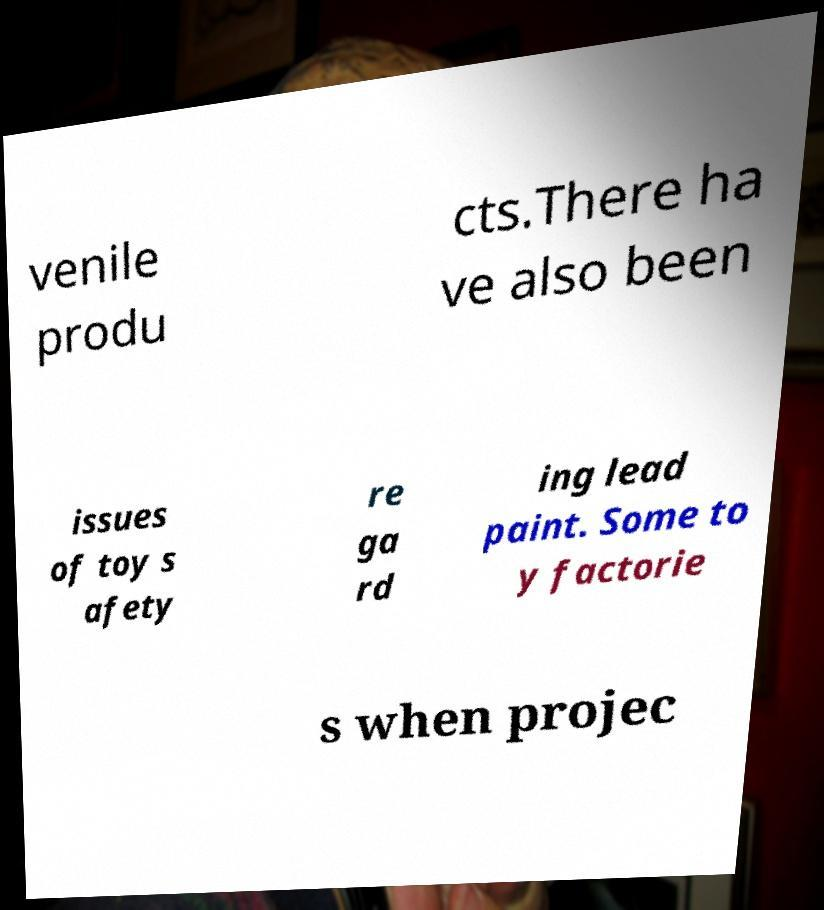I need the written content from this picture converted into text. Can you do that? venile produ cts.There ha ve also been issues of toy s afety re ga rd ing lead paint. Some to y factorie s when projec 